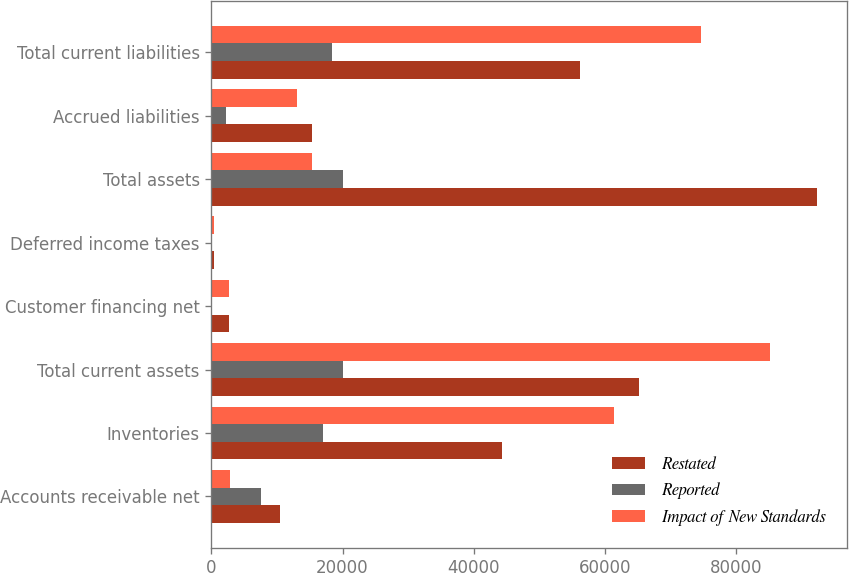<chart> <loc_0><loc_0><loc_500><loc_500><stacked_bar_chart><ecel><fcel>Accounts receivable net<fcel>Inventories<fcel>Total current assets<fcel>Customer financing net<fcel>Deferred income taxes<fcel>Total assets<fcel>Accrued liabilities<fcel>Total current liabilities<nl><fcel>Restated<fcel>10516<fcel>44344<fcel>65161<fcel>2740<fcel>341<fcel>92333<fcel>15292<fcel>56269<nl><fcel>Reported<fcel>7622<fcel>17044<fcel>20033<fcel>16<fcel>20<fcel>20029<fcel>2223<fcel>18379<nl><fcel>Impact of New Standards<fcel>2894<fcel>61388<fcel>85194<fcel>2756<fcel>321<fcel>15292<fcel>13069<fcel>74648<nl></chart> 